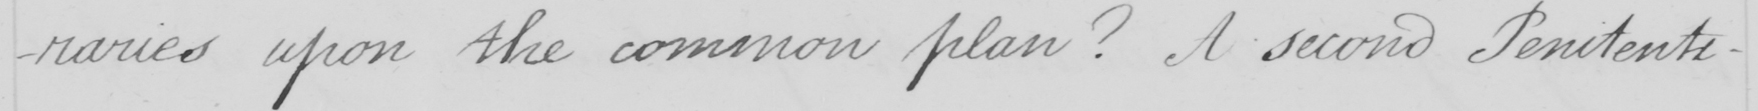Please provide the text content of this handwritten line. -raries upon the common plan ?  A second Penitent- 